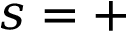<formula> <loc_0><loc_0><loc_500><loc_500>s = +</formula> 